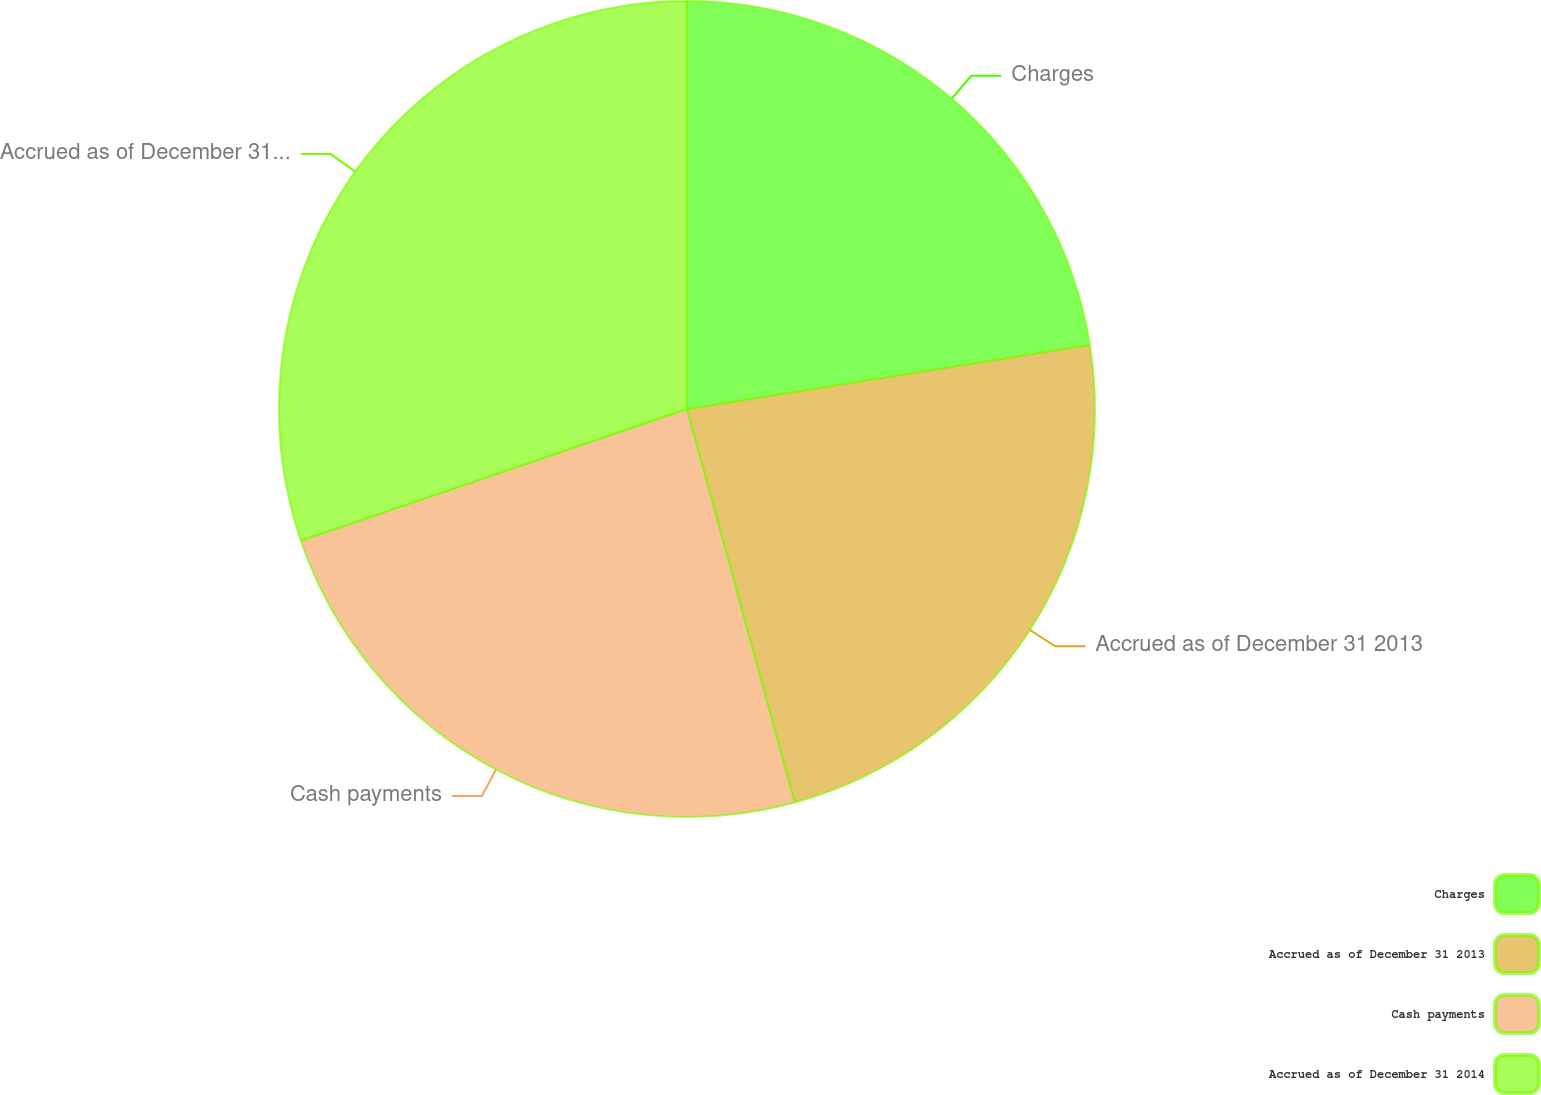<chart> <loc_0><loc_0><loc_500><loc_500><pie_chart><fcel>Charges<fcel>Accrued as of December 31 2013<fcel>Cash payments<fcel>Accrued as of December 31 2014<nl><fcel>22.48%<fcel>23.26%<fcel>24.03%<fcel>30.23%<nl></chart> 